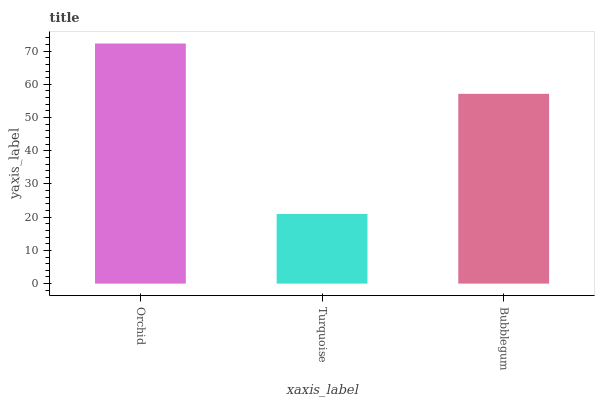Is Turquoise the minimum?
Answer yes or no. Yes. Is Orchid the maximum?
Answer yes or no. Yes. Is Bubblegum the minimum?
Answer yes or no. No. Is Bubblegum the maximum?
Answer yes or no. No. Is Bubblegum greater than Turquoise?
Answer yes or no. Yes. Is Turquoise less than Bubblegum?
Answer yes or no. Yes. Is Turquoise greater than Bubblegum?
Answer yes or no. No. Is Bubblegum less than Turquoise?
Answer yes or no. No. Is Bubblegum the high median?
Answer yes or no. Yes. Is Bubblegum the low median?
Answer yes or no. Yes. Is Orchid the high median?
Answer yes or no. No. Is Turquoise the low median?
Answer yes or no. No. 